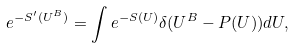Convert formula to latex. <formula><loc_0><loc_0><loc_500><loc_500>e ^ { - S ^ { \prime } ( U ^ { B } ) } = \int e ^ { - S ( U ) } \delta ( U ^ { B } - P ( U ) ) d U ,</formula> 